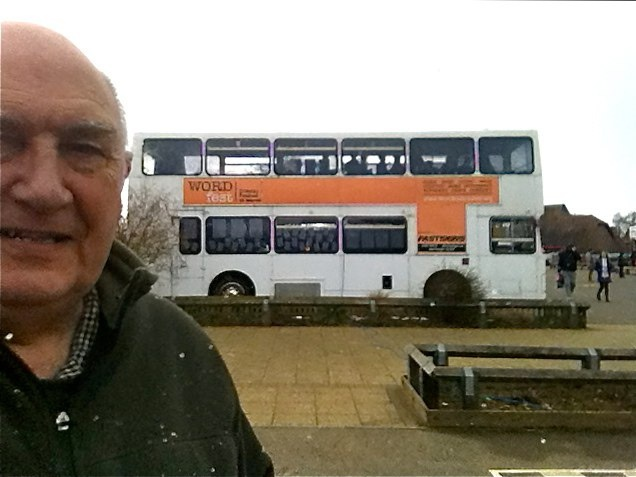Describe the objects in this image and their specific colors. I can see bus in white, darkgray, gray, black, and lightgray tones, people in white, black, maroon, gray, and brown tones, people in white, black, and gray tones, people in white, black, gray, and darkgray tones, and people in white, darkblue, blue, and navy tones in this image. 